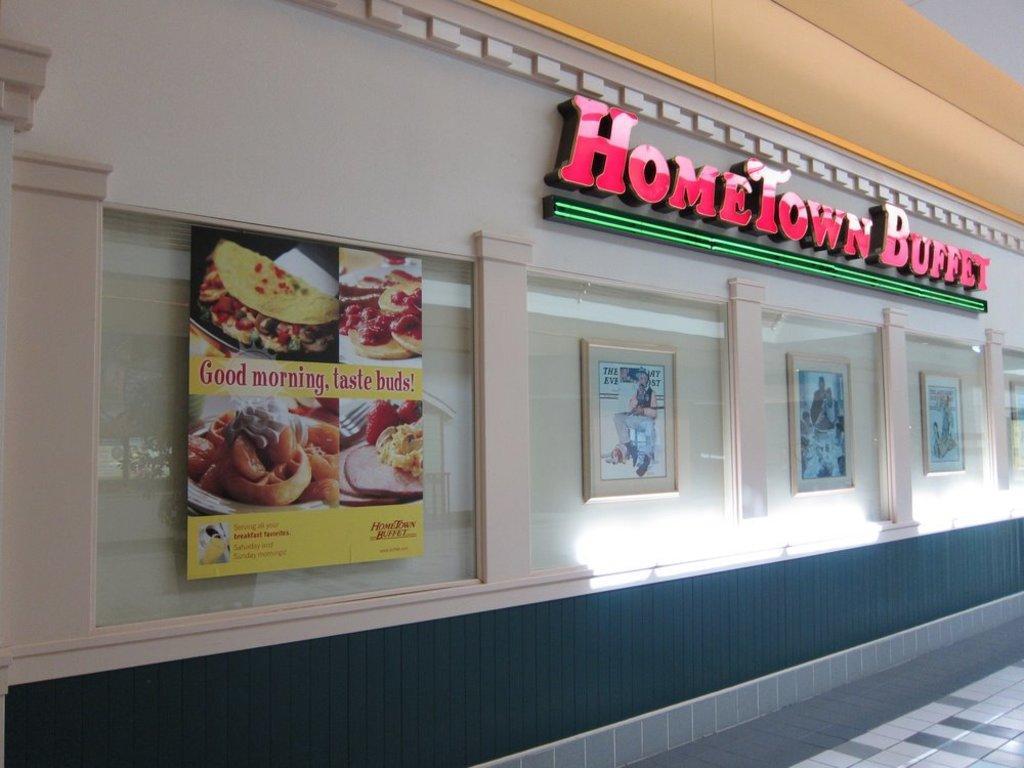In one or two sentences, can you explain what this image depicts? In this picture, we see a building or a wall in white, orange and black color. In the right bottom, we see the pavement. We see the photo frames placed on the wall. On the left side, we see the poster of the food item in yellow color is placed on the wall. On top of the building, we see the text written as "HOMETOWN BUFFET". 